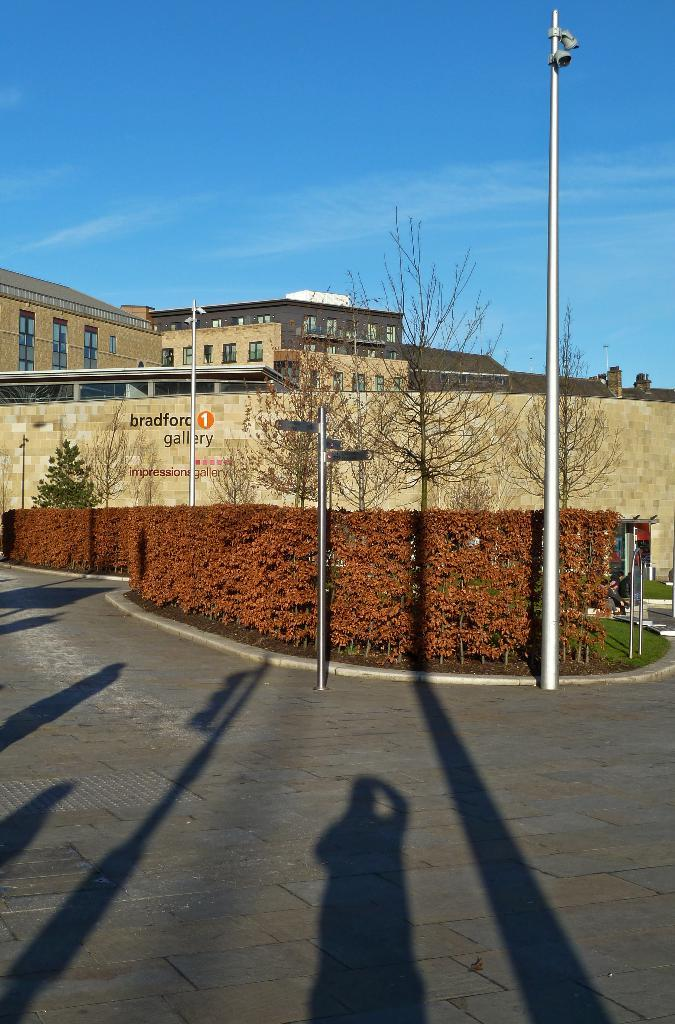What is located at the bottom of the image? There is a road at the bottom of the image. What can be seen in front of the road? There are trees and a building in front of the road. What is visible in the background of the image? The sky is visible in the background of the image. Can you tell me how many grapes are hanging from the trees in the image? There are no grapes visible in the image; the trees are not described as having grapes. What type of art is displayed on the building in the image? There is no art displayed on the building in the image; the building is not described as having any art. 